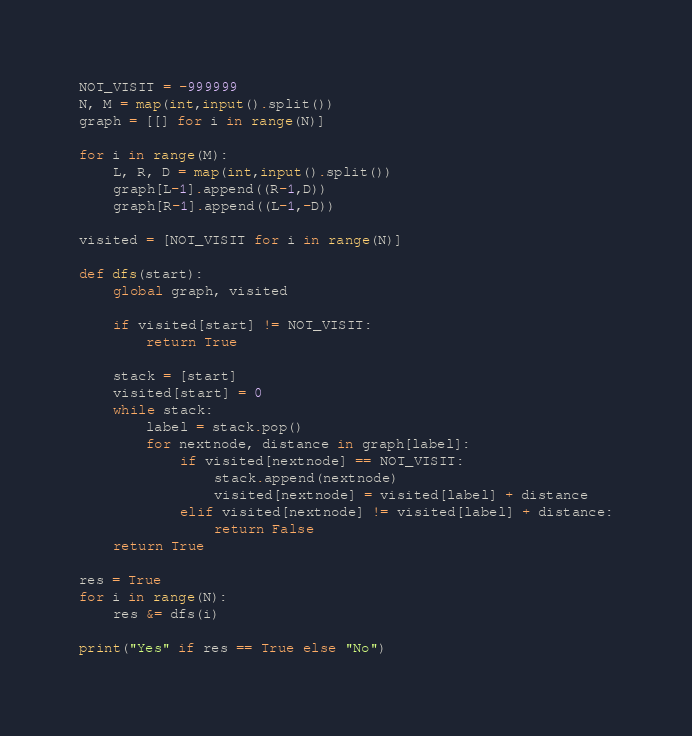<code> <loc_0><loc_0><loc_500><loc_500><_Python_>NOT_VISIT = -999999
N, M = map(int,input().split())
graph = [[] for i in range(N)]

for i in range(M):
	L, R, D = map(int,input().split())
	graph[L-1].append((R-1,D))
	graph[R-1].append((L-1,-D))

visited = [NOT_VISIT for i in range(N)]

def dfs(start):
	global graph, visited

	if visited[start] != NOT_VISIT:
		return True

	stack = [start]
	visited[start] = 0
	while stack:
		label = stack.pop()
		for nextnode, distance in graph[label]:
			if visited[nextnode] == NOT_VISIT:
				stack.append(nextnode)
				visited[nextnode] = visited[label] + distance
			elif visited[nextnode] != visited[label] + distance:
				return False
	return True

res = True
for i in range(N):
	res &= dfs(i)

print("Yes" if res == True else "No")</code> 